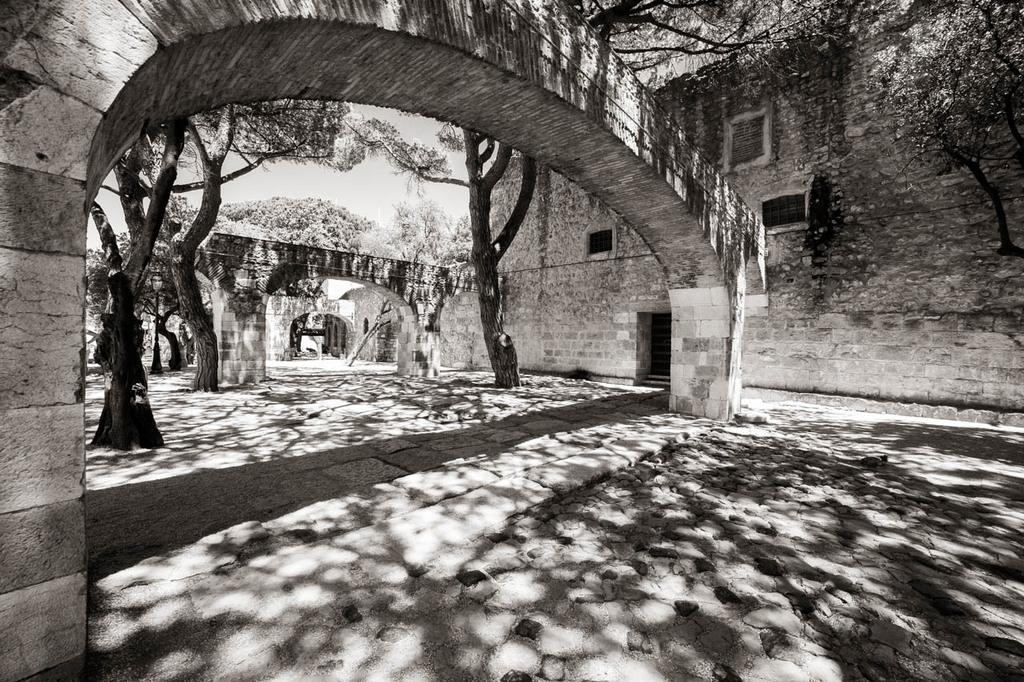What type of structures can be seen in the image? There are buildings in the image. What other natural elements are present in the image? There are trees in the image. What feature can be seen on the buildings and possibly other structures? There are windows in the image. What is visible at the top of the image? The sky is visible at the top of the image. How many boys are shown respecting their stomachs in the image? There are no boys or references to respecting stomachs in the image. 